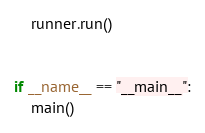Convert code to text. <code><loc_0><loc_0><loc_500><loc_500><_Python_>    runner.run()


if __name__ == "__main__":
    main()
</code> 